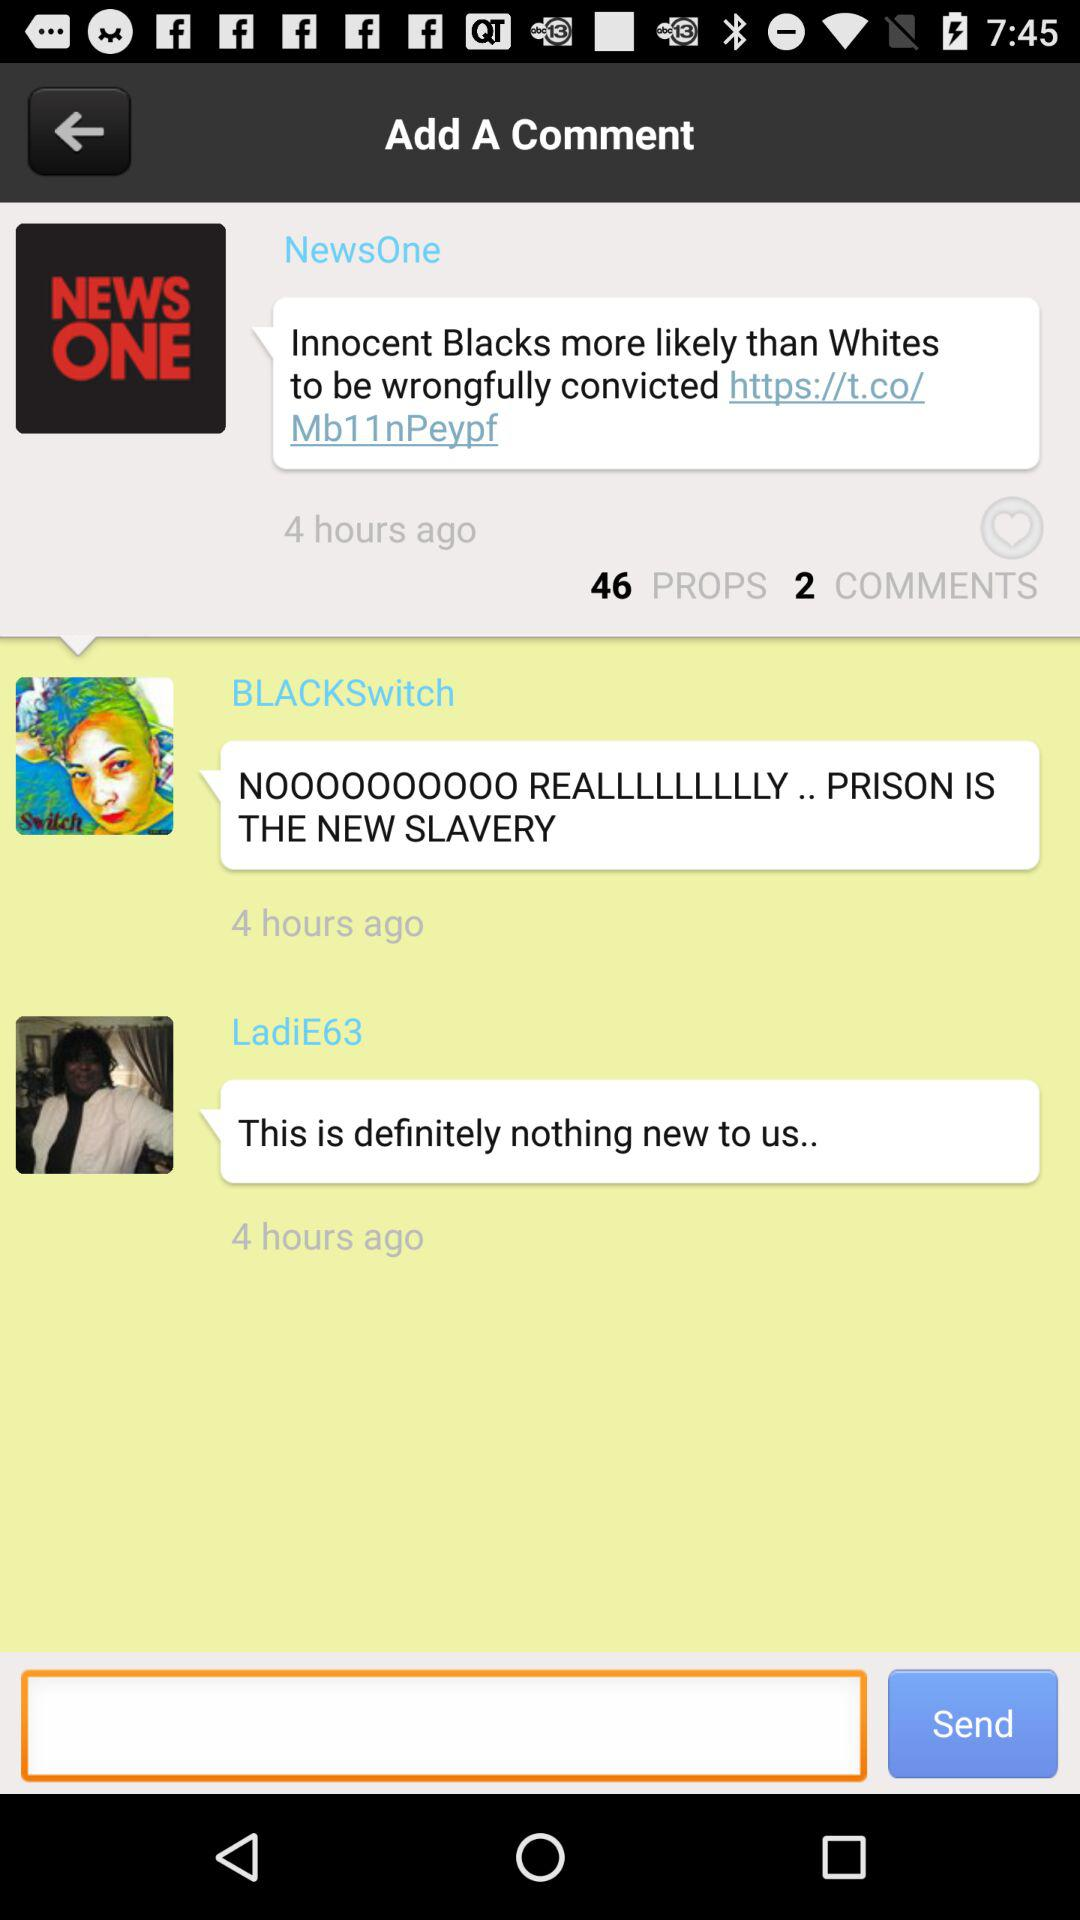How many comments are there? There are 2 comments. 